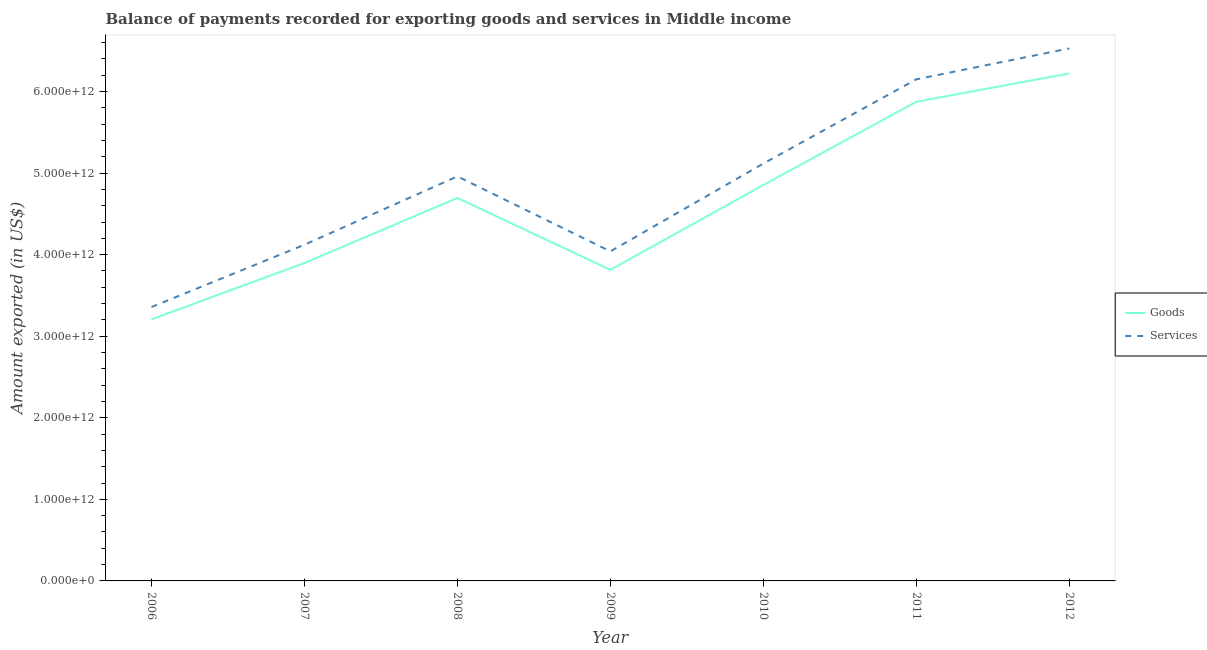Does the line corresponding to amount of goods exported intersect with the line corresponding to amount of services exported?
Offer a terse response. No. What is the amount of goods exported in 2008?
Offer a very short reply. 4.70e+12. Across all years, what is the maximum amount of goods exported?
Offer a terse response. 6.22e+12. Across all years, what is the minimum amount of services exported?
Provide a succinct answer. 3.36e+12. In which year was the amount of services exported maximum?
Provide a short and direct response. 2012. In which year was the amount of services exported minimum?
Your response must be concise. 2006. What is the total amount of goods exported in the graph?
Provide a succinct answer. 3.26e+13. What is the difference between the amount of goods exported in 2006 and that in 2010?
Provide a short and direct response. -1.65e+12. What is the difference between the amount of goods exported in 2011 and the amount of services exported in 2006?
Give a very brief answer. 2.52e+12. What is the average amount of goods exported per year?
Provide a succinct answer. 4.65e+12. In the year 2011, what is the difference between the amount of services exported and amount of goods exported?
Provide a succinct answer. 2.75e+11. In how many years, is the amount of services exported greater than 2400000000000 US$?
Provide a succinct answer. 7. What is the ratio of the amount of services exported in 2008 to that in 2011?
Ensure brevity in your answer.  0.81. Is the amount of services exported in 2010 less than that in 2012?
Provide a succinct answer. Yes. Is the difference between the amount of goods exported in 2006 and 2010 greater than the difference between the amount of services exported in 2006 and 2010?
Your response must be concise. Yes. What is the difference between the highest and the second highest amount of goods exported?
Your answer should be very brief. 3.47e+11. What is the difference between the highest and the lowest amount of services exported?
Ensure brevity in your answer.  3.17e+12. What is the difference between two consecutive major ticks on the Y-axis?
Offer a terse response. 1.00e+12. Does the graph contain any zero values?
Provide a short and direct response. No. How many legend labels are there?
Your answer should be compact. 2. How are the legend labels stacked?
Ensure brevity in your answer.  Vertical. What is the title of the graph?
Your answer should be very brief. Balance of payments recorded for exporting goods and services in Middle income. What is the label or title of the X-axis?
Your response must be concise. Year. What is the label or title of the Y-axis?
Your response must be concise. Amount exported (in US$). What is the Amount exported (in US$) in Goods in 2006?
Make the answer very short. 3.21e+12. What is the Amount exported (in US$) of Services in 2006?
Keep it short and to the point. 3.36e+12. What is the Amount exported (in US$) in Goods in 2007?
Keep it short and to the point. 3.90e+12. What is the Amount exported (in US$) in Services in 2007?
Give a very brief answer. 4.12e+12. What is the Amount exported (in US$) in Goods in 2008?
Offer a very short reply. 4.70e+12. What is the Amount exported (in US$) of Services in 2008?
Keep it short and to the point. 4.96e+12. What is the Amount exported (in US$) of Goods in 2009?
Your answer should be very brief. 3.81e+12. What is the Amount exported (in US$) of Services in 2009?
Provide a succinct answer. 4.04e+12. What is the Amount exported (in US$) in Goods in 2010?
Provide a succinct answer. 4.85e+12. What is the Amount exported (in US$) of Services in 2010?
Provide a short and direct response. 5.12e+12. What is the Amount exported (in US$) in Goods in 2011?
Offer a very short reply. 5.87e+12. What is the Amount exported (in US$) of Services in 2011?
Offer a very short reply. 6.15e+12. What is the Amount exported (in US$) of Goods in 2012?
Keep it short and to the point. 6.22e+12. What is the Amount exported (in US$) in Services in 2012?
Your answer should be compact. 6.53e+12. Across all years, what is the maximum Amount exported (in US$) of Goods?
Provide a short and direct response. 6.22e+12. Across all years, what is the maximum Amount exported (in US$) in Services?
Offer a terse response. 6.53e+12. Across all years, what is the minimum Amount exported (in US$) in Goods?
Your answer should be compact. 3.21e+12. Across all years, what is the minimum Amount exported (in US$) of Services?
Your answer should be very brief. 3.36e+12. What is the total Amount exported (in US$) in Goods in the graph?
Give a very brief answer. 3.26e+13. What is the total Amount exported (in US$) in Services in the graph?
Offer a very short reply. 3.43e+13. What is the difference between the Amount exported (in US$) in Goods in 2006 and that in 2007?
Give a very brief answer. -6.91e+11. What is the difference between the Amount exported (in US$) in Services in 2006 and that in 2007?
Your answer should be very brief. -7.63e+11. What is the difference between the Amount exported (in US$) in Goods in 2006 and that in 2008?
Make the answer very short. -1.49e+12. What is the difference between the Amount exported (in US$) in Services in 2006 and that in 2008?
Keep it short and to the point. -1.60e+12. What is the difference between the Amount exported (in US$) in Goods in 2006 and that in 2009?
Make the answer very short. -6.08e+11. What is the difference between the Amount exported (in US$) in Services in 2006 and that in 2009?
Your answer should be very brief. -6.82e+11. What is the difference between the Amount exported (in US$) in Goods in 2006 and that in 2010?
Keep it short and to the point. -1.65e+12. What is the difference between the Amount exported (in US$) of Services in 2006 and that in 2010?
Keep it short and to the point. -1.76e+12. What is the difference between the Amount exported (in US$) in Goods in 2006 and that in 2011?
Provide a succinct answer. -2.67e+12. What is the difference between the Amount exported (in US$) of Services in 2006 and that in 2011?
Give a very brief answer. -2.79e+12. What is the difference between the Amount exported (in US$) in Goods in 2006 and that in 2012?
Make the answer very short. -3.02e+12. What is the difference between the Amount exported (in US$) in Services in 2006 and that in 2012?
Keep it short and to the point. -3.17e+12. What is the difference between the Amount exported (in US$) of Goods in 2007 and that in 2008?
Your answer should be compact. -7.97e+11. What is the difference between the Amount exported (in US$) of Services in 2007 and that in 2008?
Keep it short and to the point. -8.39e+11. What is the difference between the Amount exported (in US$) of Goods in 2007 and that in 2009?
Provide a short and direct response. 8.34e+1. What is the difference between the Amount exported (in US$) in Services in 2007 and that in 2009?
Give a very brief answer. 8.11e+1. What is the difference between the Amount exported (in US$) in Goods in 2007 and that in 2010?
Provide a short and direct response. -9.56e+11. What is the difference between the Amount exported (in US$) in Services in 2007 and that in 2010?
Provide a short and direct response. -9.96e+11. What is the difference between the Amount exported (in US$) of Goods in 2007 and that in 2011?
Your answer should be very brief. -1.98e+12. What is the difference between the Amount exported (in US$) of Services in 2007 and that in 2011?
Your answer should be compact. -2.03e+12. What is the difference between the Amount exported (in US$) in Goods in 2007 and that in 2012?
Give a very brief answer. -2.32e+12. What is the difference between the Amount exported (in US$) of Services in 2007 and that in 2012?
Your answer should be very brief. -2.41e+12. What is the difference between the Amount exported (in US$) in Goods in 2008 and that in 2009?
Keep it short and to the point. 8.81e+11. What is the difference between the Amount exported (in US$) of Services in 2008 and that in 2009?
Offer a very short reply. 9.20e+11. What is the difference between the Amount exported (in US$) of Goods in 2008 and that in 2010?
Keep it short and to the point. -1.59e+11. What is the difference between the Amount exported (in US$) of Services in 2008 and that in 2010?
Provide a succinct answer. -1.57e+11. What is the difference between the Amount exported (in US$) of Goods in 2008 and that in 2011?
Offer a very short reply. -1.18e+12. What is the difference between the Amount exported (in US$) of Services in 2008 and that in 2011?
Make the answer very short. -1.19e+12. What is the difference between the Amount exported (in US$) of Goods in 2008 and that in 2012?
Your response must be concise. -1.53e+12. What is the difference between the Amount exported (in US$) in Services in 2008 and that in 2012?
Provide a short and direct response. -1.57e+12. What is the difference between the Amount exported (in US$) in Goods in 2009 and that in 2010?
Your response must be concise. -1.04e+12. What is the difference between the Amount exported (in US$) of Services in 2009 and that in 2010?
Your response must be concise. -1.08e+12. What is the difference between the Amount exported (in US$) in Goods in 2009 and that in 2011?
Provide a succinct answer. -2.06e+12. What is the difference between the Amount exported (in US$) in Services in 2009 and that in 2011?
Ensure brevity in your answer.  -2.11e+12. What is the difference between the Amount exported (in US$) in Goods in 2009 and that in 2012?
Provide a succinct answer. -2.41e+12. What is the difference between the Amount exported (in US$) of Services in 2009 and that in 2012?
Keep it short and to the point. -2.49e+12. What is the difference between the Amount exported (in US$) of Goods in 2010 and that in 2011?
Your answer should be compact. -1.02e+12. What is the difference between the Amount exported (in US$) of Services in 2010 and that in 2011?
Offer a terse response. -1.03e+12. What is the difference between the Amount exported (in US$) in Goods in 2010 and that in 2012?
Give a very brief answer. -1.37e+12. What is the difference between the Amount exported (in US$) in Services in 2010 and that in 2012?
Keep it short and to the point. -1.41e+12. What is the difference between the Amount exported (in US$) of Goods in 2011 and that in 2012?
Provide a short and direct response. -3.47e+11. What is the difference between the Amount exported (in US$) of Services in 2011 and that in 2012?
Offer a terse response. -3.79e+11. What is the difference between the Amount exported (in US$) in Goods in 2006 and the Amount exported (in US$) in Services in 2007?
Offer a very short reply. -9.15e+11. What is the difference between the Amount exported (in US$) of Goods in 2006 and the Amount exported (in US$) of Services in 2008?
Keep it short and to the point. -1.75e+12. What is the difference between the Amount exported (in US$) in Goods in 2006 and the Amount exported (in US$) in Services in 2009?
Offer a very short reply. -8.34e+11. What is the difference between the Amount exported (in US$) in Goods in 2006 and the Amount exported (in US$) in Services in 2010?
Provide a short and direct response. -1.91e+12. What is the difference between the Amount exported (in US$) in Goods in 2006 and the Amount exported (in US$) in Services in 2011?
Give a very brief answer. -2.94e+12. What is the difference between the Amount exported (in US$) of Goods in 2006 and the Amount exported (in US$) of Services in 2012?
Keep it short and to the point. -3.32e+12. What is the difference between the Amount exported (in US$) of Goods in 2007 and the Amount exported (in US$) of Services in 2008?
Your response must be concise. -1.06e+12. What is the difference between the Amount exported (in US$) in Goods in 2007 and the Amount exported (in US$) in Services in 2009?
Make the answer very short. -1.43e+11. What is the difference between the Amount exported (in US$) of Goods in 2007 and the Amount exported (in US$) of Services in 2010?
Your answer should be compact. -1.22e+12. What is the difference between the Amount exported (in US$) in Goods in 2007 and the Amount exported (in US$) in Services in 2011?
Offer a terse response. -2.25e+12. What is the difference between the Amount exported (in US$) in Goods in 2007 and the Amount exported (in US$) in Services in 2012?
Provide a short and direct response. -2.63e+12. What is the difference between the Amount exported (in US$) of Goods in 2008 and the Amount exported (in US$) of Services in 2009?
Ensure brevity in your answer.  6.55e+11. What is the difference between the Amount exported (in US$) in Goods in 2008 and the Amount exported (in US$) in Services in 2010?
Keep it short and to the point. -4.22e+11. What is the difference between the Amount exported (in US$) in Goods in 2008 and the Amount exported (in US$) in Services in 2011?
Ensure brevity in your answer.  -1.46e+12. What is the difference between the Amount exported (in US$) of Goods in 2008 and the Amount exported (in US$) of Services in 2012?
Keep it short and to the point. -1.83e+12. What is the difference between the Amount exported (in US$) of Goods in 2009 and the Amount exported (in US$) of Services in 2010?
Your answer should be very brief. -1.30e+12. What is the difference between the Amount exported (in US$) of Goods in 2009 and the Amount exported (in US$) of Services in 2011?
Provide a succinct answer. -2.34e+12. What is the difference between the Amount exported (in US$) of Goods in 2009 and the Amount exported (in US$) of Services in 2012?
Provide a succinct answer. -2.71e+12. What is the difference between the Amount exported (in US$) in Goods in 2010 and the Amount exported (in US$) in Services in 2011?
Offer a terse response. -1.30e+12. What is the difference between the Amount exported (in US$) in Goods in 2010 and the Amount exported (in US$) in Services in 2012?
Give a very brief answer. -1.67e+12. What is the difference between the Amount exported (in US$) in Goods in 2011 and the Amount exported (in US$) in Services in 2012?
Offer a terse response. -6.54e+11. What is the average Amount exported (in US$) of Goods per year?
Keep it short and to the point. 4.65e+12. What is the average Amount exported (in US$) of Services per year?
Offer a terse response. 4.90e+12. In the year 2006, what is the difference between the Amount exported (in US$) of Goods and Amount exported (in US$) of Services?
Offer a terse response. -1.51e+11. In the year 2007, what is the difference between the Amount exported (in US$) in Goods and Amount exported (in US$) in Services?
Give a very brief answer. -2.24e+11. In the year 2008, what is the difference between the Amount exported (in US$) in Goods and Amount exported (in US$) in Services?
Offer a terse response. -2.65e+11. In the year 2009, what is the difference between the Amount exported (in US$) of Goods and Amount exported (in US$) of Services?
Ensure brevity in your answer.  -2.26e+11. In the year 2010, what is the difference between the Amount exported (in US$) in Goods and Amount exported (in US$) in Services?
Keep it short and to the point. -2.63e+11. In the year 2011, what is the difference between the Amount exported (in US$) in Goods and Amount exported (in US$) in Services?
Make the answer very short. -2.75e+11. In the year 2012, what is the difference between the Amount exported (in US$) in Goods and Amount exported (in US$) in Services?
Ensure brevity in your answer.  -3.07e+11. What is the ratio of the Amount exported (in US$) in Goods in 2006 to that in 2007?
Offer a terse response. 0.82. What is the ratio of the Amount exported (in US$) in Services in 2006 to that in 2007?
Keep it short and to the point. 0.81. What is the ratio of the Amount exported (in US$) of Goods in 2006 to that in 2008?
Your response must be concise. 0.68. What is the ratio of the Amount exported (in US$) in Services in 2006 to that in 2008?
Your answer should be very brief. 0.68. What is the ratio of the Amount exported (in US$) of Goods in 2006 to that in 2009?
Provide a succinct answer. 0.84. What is the ratio of the Amount exported (in US$) of Services in 2006 to that in 2009?
Give a very brief answer. 0.83. What is the ratio of the Amount exported (in US$) in Goods in 2006 to that in 2010?
Offer a terse response. 0.66. What is the ratio of the Amount exported (in US$) in Services in 2006 to that in 2010?
Give a very brief answer. 0.66. What is the ratio of the Amount exported (in US$) of Goods in 2006 to that in 2011?
Give a very brief answer. 0.55. What is the ratio of the Amount exported (in US$) of Services in 2006 to that in 2011?
Keep it short and to the point. 0.55. What is the ratio of the Amount exported (in US$) in Goods in 2006 to that in 2012?
Your answer should be compact. 0.52. What is the ratio of the Amount exported (in US$) in Services in 2006 to that in 2012?
Keep it short and to the point. 0.51. What is the ratio of the Amount exported (in US$) in Goods in 2007 to that in 2008?
Give a very brief answer. 0.83. What is the ratio of the Amount exported (in US$) in Services in 2007 to that in 2008?
Your answer should be compact. 0.83. What is the ratio of the Amount exported (in US$) of Goods in 2007 to that in 2009?
Ensure brevity in your answer.  1.02. What is the ratio of the Amount exported (in US$) in Services in 2007 to that in 2009?
Provide a short and direct response. 1.02. What is the ratio of the Amount exported (in US$) in Goods in 2007 to that in 2010?
Make the answer very short. 0.8. What is the ratio of the Amount exported (in US$) of Services in 2007 to that in 2010?
Your answer should be compact. 0.81. What is the ratio of the Amount exported (in US$) of Goods in 2007 to that in 2011?
Your response must be concise. 0.66. What is the ratio of the Amount exported (in US$) in Services in 2007 to that in 2011?
Provide a succinct answer. 0.67. What is the ratio of the Amount exported (in US$) in Goods in 2007 to that in 2012?
Make the answer very short. 0.63. What is the ratio of the Amount exported (in US$) of Services in 2007 to that in 2012?
Provide a short and direct response. 0.63. What is the ratio of the Amount exported (in US$) of Goods in 2008 to that in 2009?
Your response must be concise. 1.23. What is the ratio of the Amount exported (in US$) of Services in 2008 to that in 2009?
Your answer should be compact. 1.23. What is the ratio of the Amount exported (in US$) in Goods in 2008 to that in 2010?
Your answer should be very brief. 0.97. What is the ratio of the Amount exported (in US$) of Services in 2008 to that in 2010?
Make the answer very short. 0.97. What is the ratio of the Amount exported (in US$) of Goods in 2008 to that in 2011?
Provide a short and direct response. 0.8. What is the ratio of the Amount exported (in US$) in Services in 2008 to that in 2011?
Your answer should be very brief. 0.81. What is the ratio of the Amount exported (in US$) of Goods in 2008 to that in 2012?
Provide a short and direct response. 0.75. What is the ratio of the Amount exported (in US$) of Services in 2008 to that in 2012?
Offer a very short reply. 0.76. What is the ratio of the Amount exported (in US$) of Goods in 2009 to that in 2010?
Provide a short and direct response. 0.79. What is the ratio of the Amount exported (in US$) in Services in 2009 to that in 2010?
Offer a very short reply. 0.79. What is the ratio of the Amount exported (in US$) in Goods in 2009 to that in 2011?
Provide a short and direct response. 0.65. What is the ratio of the Amount exported (in US$) of Services in 2009 to that in 2011?
Offer a very short reply. 0.66. What is the ratio of the Amount exported (in US$) in Goods in 2009 to that in 2012?
Your response must be concise. 0.61. What is the ratio of the Amount exported (in US$) in Services in 2009 to that in 2012?
Provide a short and direct response. 0.62. What is the ratio of the Amount exported (in US$) of Goods in 2010 to that in 2011?
Give a very brief answer. 0.83. What is the ratio of the Amount exported (in US$) in Services in 2010 to that in 2011?
Keep it short and to the point. 0.83. What is the ratio of the Amount exported (in US$) in Goods in 2010 to that in 2012?
Offer a terse response. 0.78. What is the ratio of the Amount exported (in US$) of Services in 2010 to that in 2012?
Ensure brevity in your answer.  0.78. What is the ratio of the Amount exported (in US$) of Goods in 2011 to that in 2012?
Make the answer very short. 0.94. What is the ratio of the Amount exported (in US$) of Services in 2011 to that in 2012?
Offer a terse response. 0.94. What is the difference between the highest and the second highest Amount exported (in US$) in Goods?
Offer a very short reply. 3.47e+11. What is the difference between the highest and the second highest Amount exported (in US$) in Services?
Make the answer very short. 3.79e+11. What is the difference between the highest and the lowest Amount exported (in US$) of Goods?
Your response must be concise. 3.02e+12. What is the difference between the highest and the lowest Amount exported (in US$) in Services?
Your answer should be compact. 3.17e+12. 